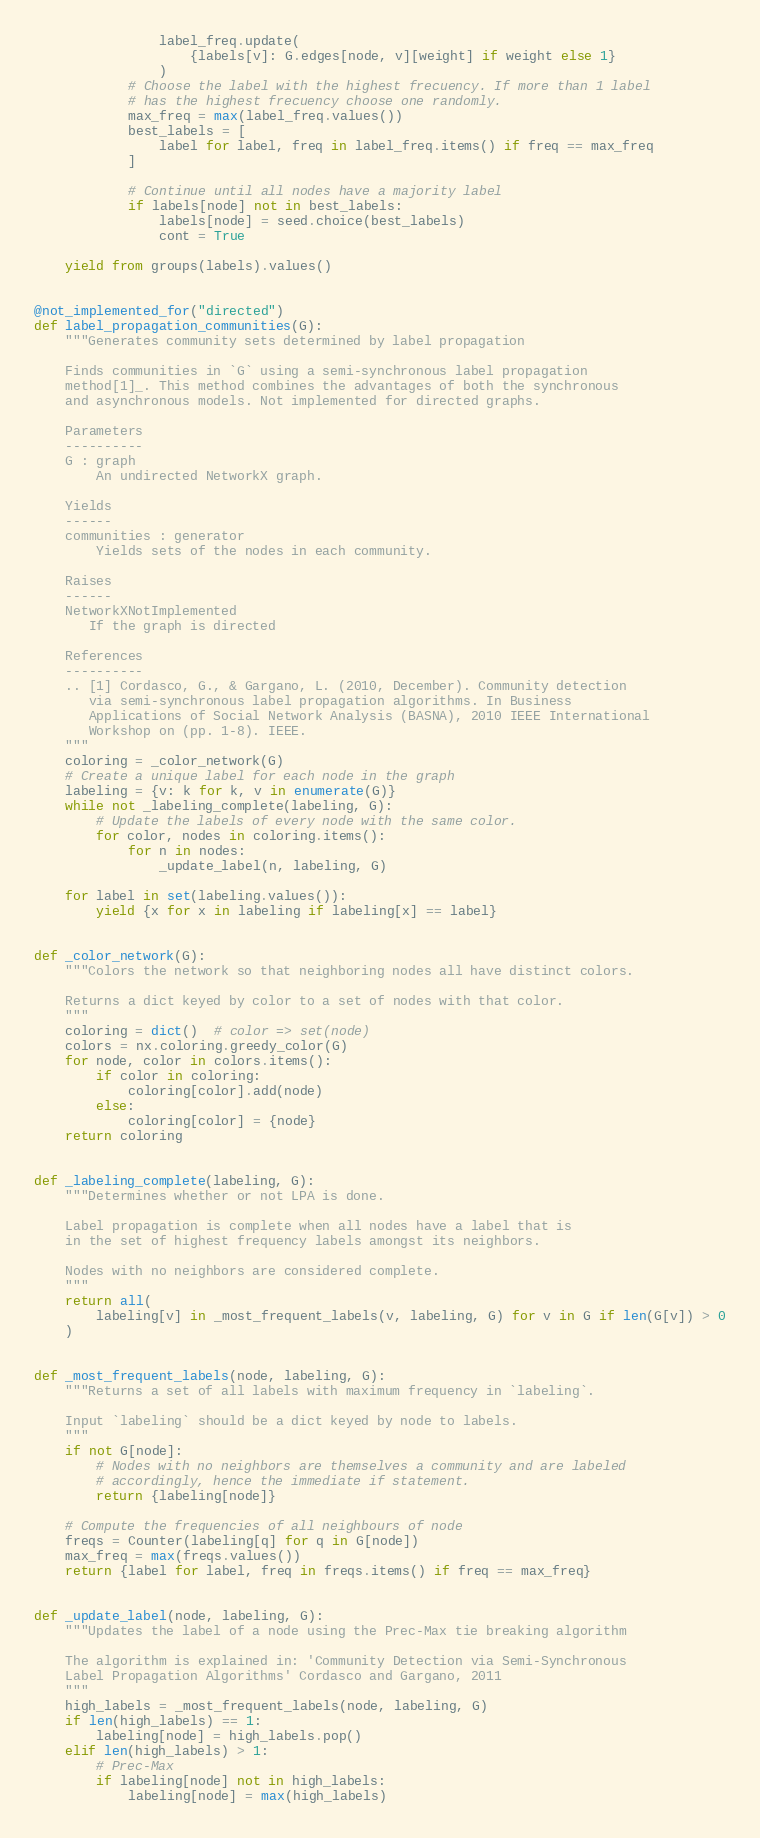Convert code to text. <code><loc_0><loc_0><loc_500><loc_500><_Python_>                label_freq.update(
                    {labels[v]: G.edges[node, v][weight] if weight else 1}
                )
            # Choose the label with the highest frecuency. If more than 1 label
            # has the highest frecuency choose one randomly.
            max_freq = max(label_freq.values())
            best_labels = [
                label for label, freq in label_freq.items() if freq == max_freq
            ]

            # Continue until all nodes have a majority label
            if labels[node] not in best_labels:
                labels[node] = seed.choice(best_labels)
                cont = True

    yield from groups(labels).values()


@not_implemented_for("directed")
def label_propagation_communities(G):
    """Generates community sets determined by label propagation

    Finds communities in `G` using a semi-synchronous label propagation
    method[1]_. This method combines the advantages of both the synchronous
    and asynchronous models. Not implemented for directed graphs.

    Parameters
    ----------
    G : graph
        An undirected NetworkX graph.

    Yields
    ------
    communities : generator
        Yields sets of the nodes in each community.

    Raises
    ------
    NetworkXNotImplemented
       If the graph is directed

    References
    ----------
    .. [1] Cordasco, G., & Gargano, L. (2010, December). Community detection
       via semi-synchronous label propagation algorithms. In Business
       Applications of Social Network Analysis (BASNA), 2010 IEEE International
       Workshop on (pp. 1-8). IEEE.
    """
    coloring = _color_network(G)
    # Create a unique label for each node in the graph
    labeling = {v: k for k, v in enumerate(G)}
    while not _labeling_complete(labeling, G):
        # Update the labels of every node with the same color.
        for color, nodes in coloring.items():
            for n in nodes:
                _update_label(n, labeling, G)

    for label in set(labeling.values()):
        yield {x for x in labeling if labeling[x] == label}


def _color_network(G):
    """Colors the network so that neighboring nodes all have distinct colors.

    Returns a dict keyed by color to a set of nodes with that color.
    """
    coloring = dict()  # color => set(node)
    colors = nx.coloring.greedy_color(G)
    for node, color in colors.items():
        if color in coloring:
            coloring[color].add(node)
        else:
            coloring[color] = {node}
    return coloring


def _labeling_complete(labeling, G):
    """Determines whether or not LPA is done.

    Label propagation is complete when all nodes have a label that is
    in the set of highest frequency labels amongst its neighbors.

    Nodes with no neighbors are considered complete.
    """
    return all(
        labeling[v] in _most_frequent_labels(v, labeling, G) for v in G if len(G[v]) > 0
    )


def _most_frequent_labels(node, labeling, G):
    """Returns a set of all labels with maximum frequency in `labeling`.

    Input `labeling` should be a dict keyed by node to labels.
    """
    if not G[node]:
        # Nodes with no neighbors are themselves a community and are labeled
        # accordingly, hence the immediate if statement.
        return {labeling[node]}

    # Compute the frequencies of all neighbours of node
    freqs = Counter(labeling[q] for q in G[node])
    max_freq = max(freqs.values())
    return {label for label, freq in freqs.items() if freq == max_freq}


def _update_label(node, labeling, G):
    """Updates the label of a node using the Prec-Max tie breaking algorithm

    The algorithm is explained in: 'Community Detection via Semi-Synchronous
    Label Propagation Algorithms' Cordasco and Gargano, 2011
    """
    high_labels = _most_frequent_labels(node, labeling, G)
    if len(high_labels) == 1:
        labeling[node] = high_labels.pop()
    elif len(high_labels) > 1:
        # Prec-Max
        if labeling[node] not in high_labels:
            labeling[node] = max(high_labels)
</code> 